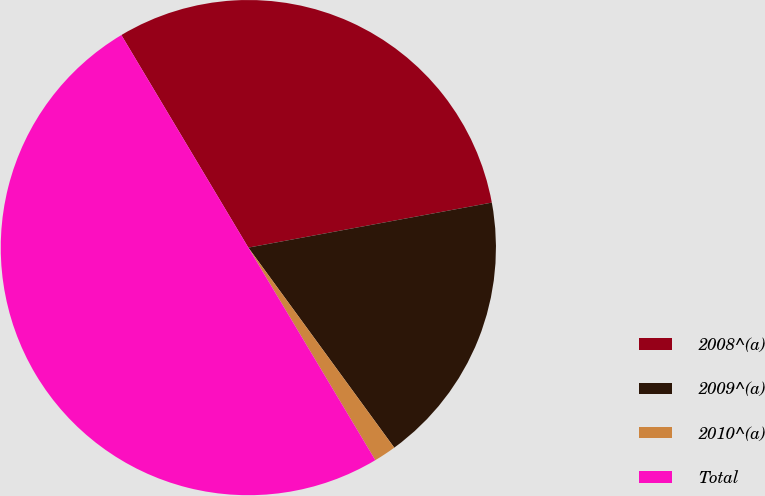Convert chart. <chart><loc_0><loc_0><loc_500><loc_500><pie_chart><fcel>2008^(a)<fcel>2009^(a)<fcel>2010^(a)<fcel>Total<nl><fcel>30.66%<fcel>17.88%<fcel>1.46%<fcel>50.0%<nl></chart> 